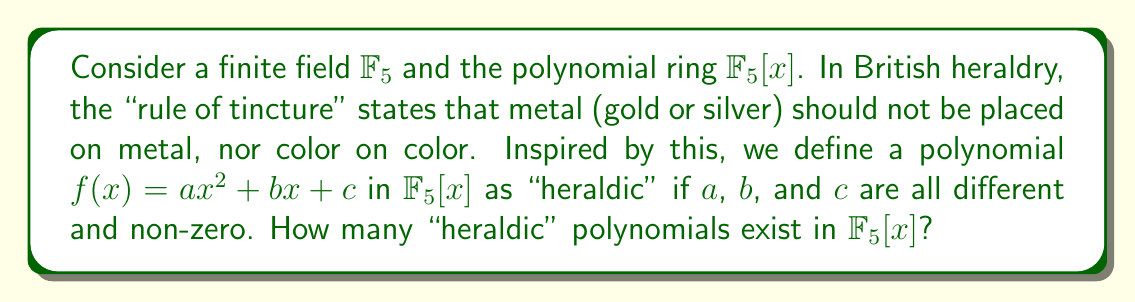What is the answer to this math problem? Let's approach this step-by-step:

1) In $\mathbb{F}_5$, we have 5 elements: $\{0, 1, 2, 3, 4\}$.

2) For a polynomial to be "heraldic", we need to choose $a$, $b$, and $c$ such that:
   - They are all different from each other
   - They are all non-zero

3) Let's count the possibilities:
   - For $a$, we have 4 choices (1, 2, 3, 4)
   - For $b$, we have 3 choices (the remaining non-zero elements different from $a$)
   - For $c$, we have 2 choices (the remaining non-zero elements different from $a$ and $b$)

4) By the multiplication principle, the total number of ways to choose $a$, $b$, and $c$ is:

   $$4 \times 3 \times 2 = 24$$

Therefore, there are 24 "heraldic" polynomials in $\mathbb{F}_5[x]$.
Answer: 24 